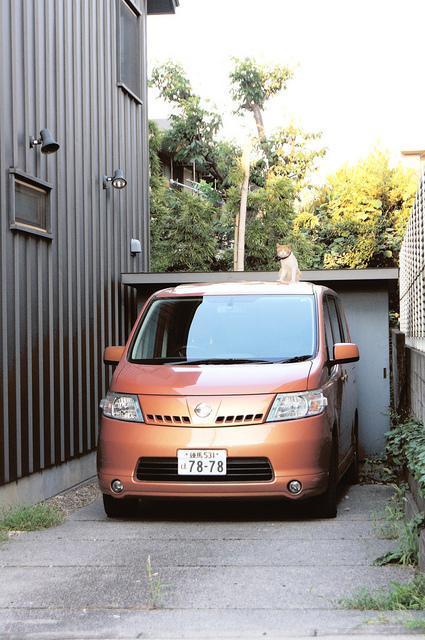How many black dogs are on the bed?
Give a very brief answer. 0. 